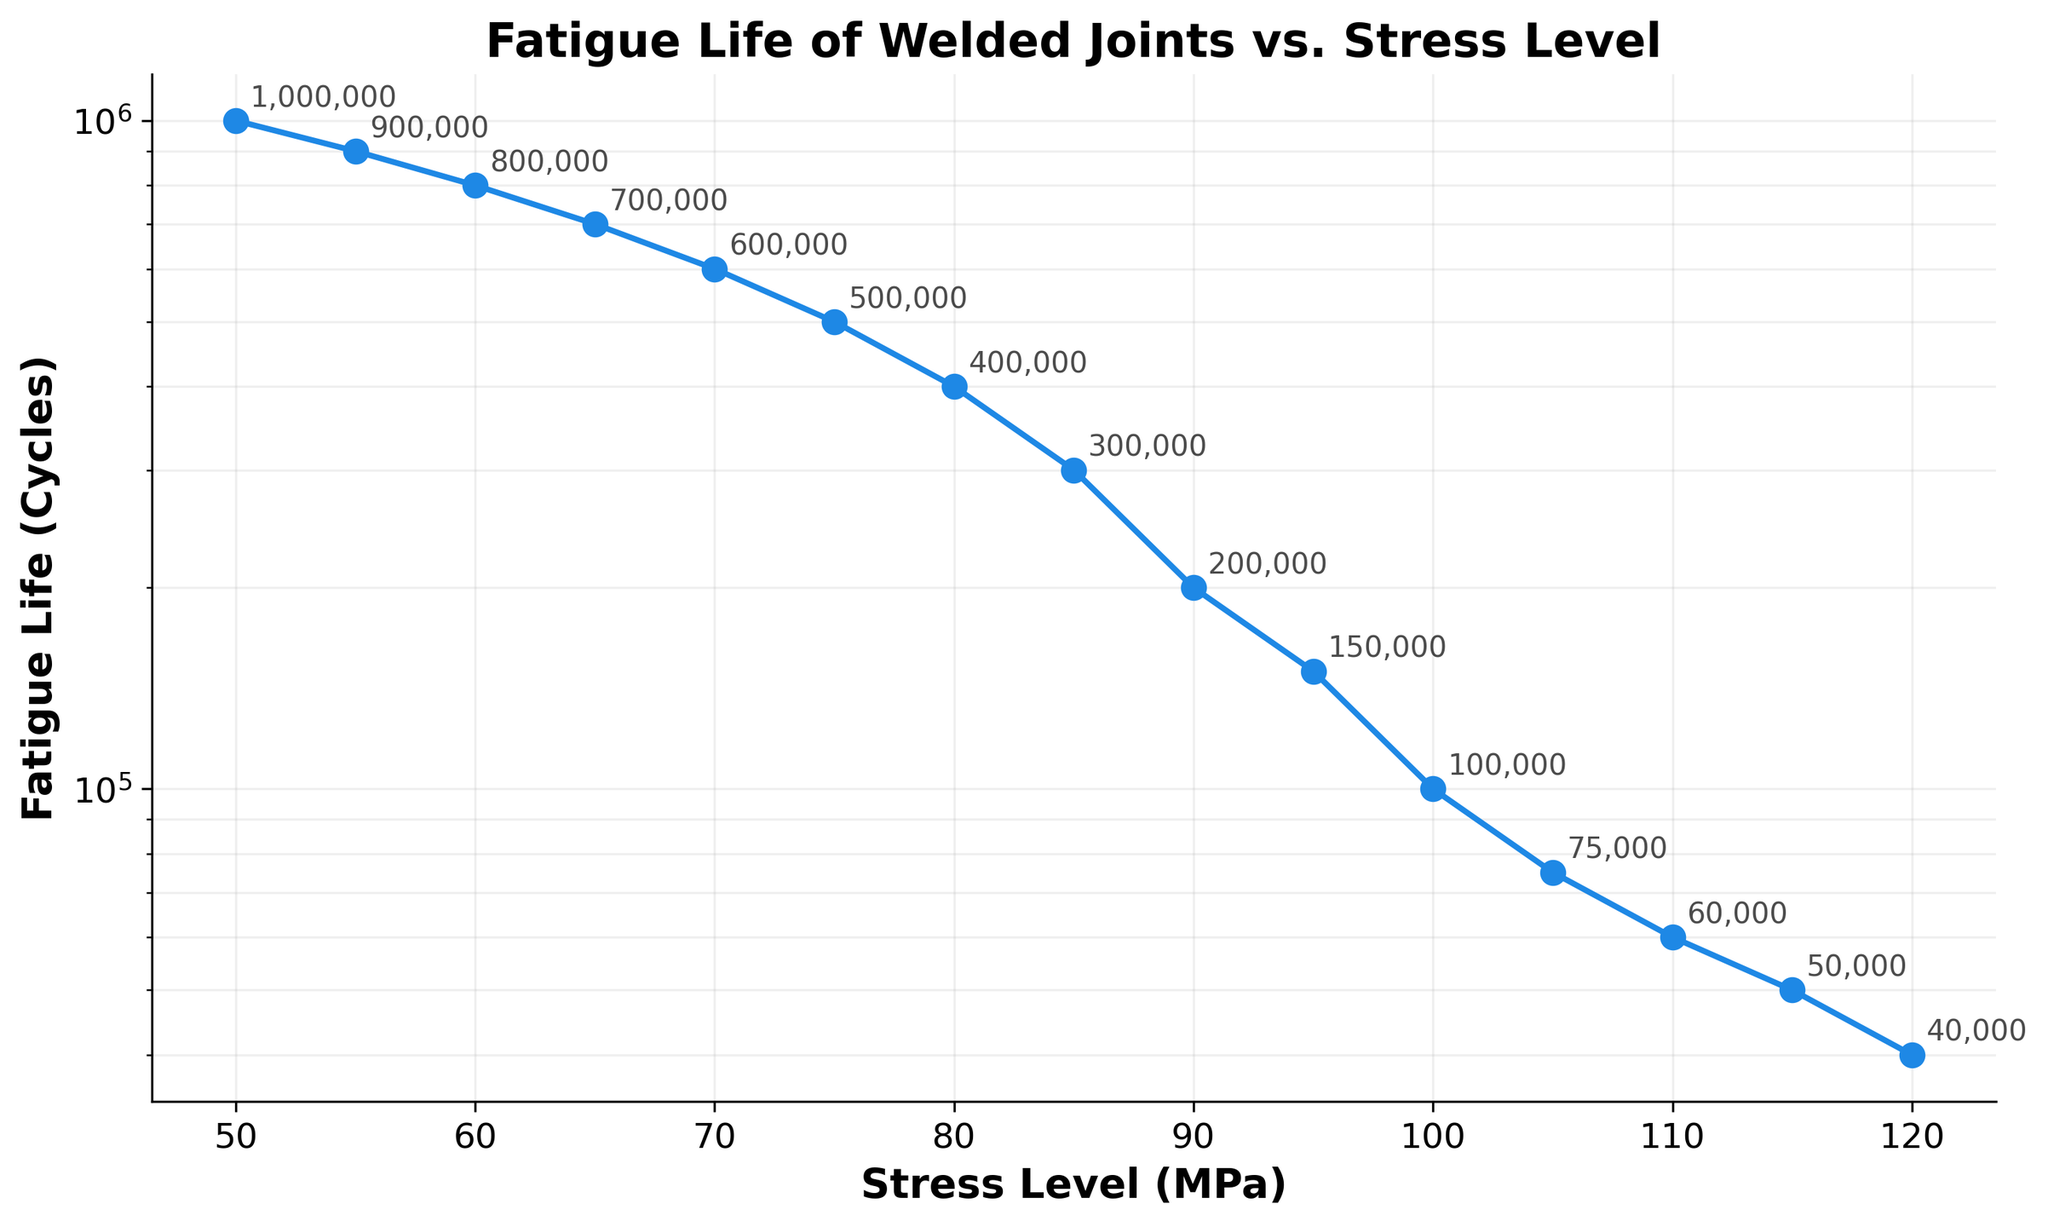What is the title of the plot? The title of the plot is displayed at the top of the figure. It reads "Fatigue Life of Welded Joints vs. Stress Level".
Answer: Fatigue Life of Welded Joints vs. Stress Level What is the y-axis scale of the plot? Observing the y-axis, it uses a logarithmic scale as indicated by the uneven intervals and "log" label within the code.
Answer: Logarithmic How does the fatigue life change as the stress level increases? As shown in the line plot, the fatigue life decreases as the stress level increases. This is evident from the downward trend of the line.
Answer: It decreases At what stress level is the fatigue life approximately 100,000 cycles? By tracing the plot, an annotation indicates that the fatigue life is 100,000 cycles at a stress level of 100 MPa.
Answer: 100 MPa What is the difference in fatigue life between 70 MPa and 90 MPa stress levels? Referring to the annotations, the fatigue life at 70 MPa is 600,000 cycles, and at 90 MPa it is 200,000 cycles. The difference is 600,000 - 200,000 = 400,000 cycles.
Answer: 400,000 cycles What stress level corresponds to the highest fatigue life? The highest fatigue life is annotated at 50 MPa, as this indicates the largest numerical value, 1,000,000 cycles, on the plot.
Answer: 50 MPa How many data points are there in the plot? Counting the markers on the plot, there are a total of 15 data points on the line.
Answer: 15 By what factor does the fatigue life decrease when moving from 80 MPa to 110 MPa stress level? At 80 MPa, the fatigue life is 400,000 cycles, and at 110 MPa, it is 60,000 cycles. The decrease factor is 400,000 / 60,000 ≈ 6.67.
Answer: Approximately 6.67 Which stress level experiences the sharpest drop in fatigue life between adjacent points? By examining the annotations and the steepness of the line, the most significant drop occurs between 95 MPa (150,000 cycles) and 100 MPa (100,000 cycles), a difference of 50,000 cycles.
Answer: Between 95 MPa and 100 MPa What can be said about the trend of the fatigue life in relation to the stress levels based on this line plot? The line plot overall trend demonstrates that fatigue life exponentially drops as stress levels increase, highlighted by the consistent downward slope in a log scale.
Answer: Exponential decrease 